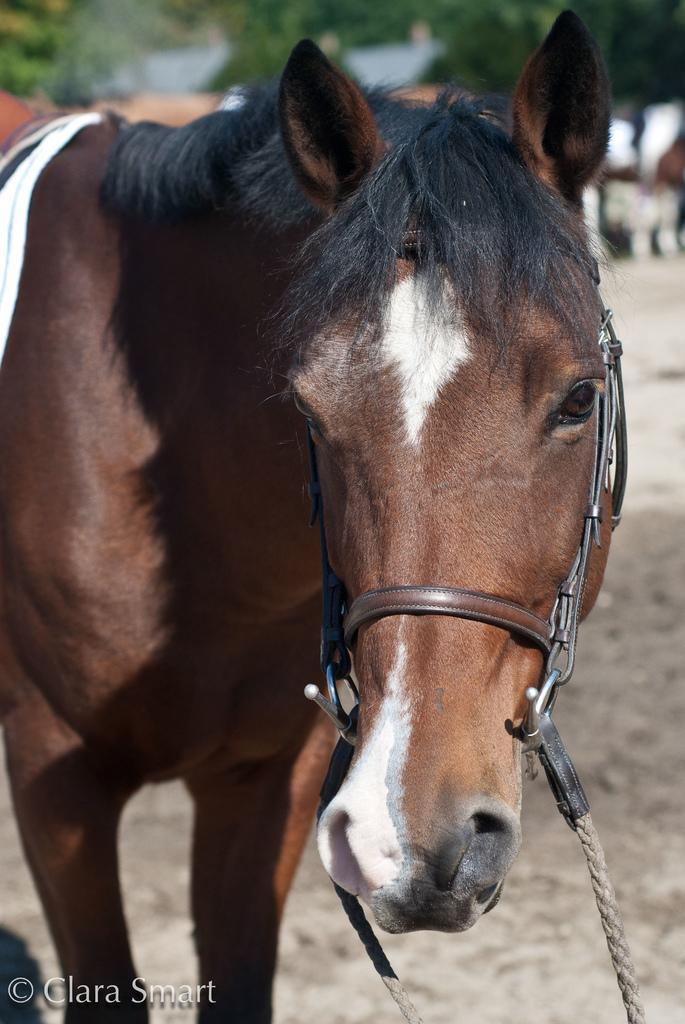What type of animal is in the image? The specific type of animal cannot be determined from the provided facts. Can you describe the background of the image? The background of the image is blurry. How much salt is visible on the animal in the image? There is no salt visible on the animal in the image, as the provided facts do not mention anything about salt. 